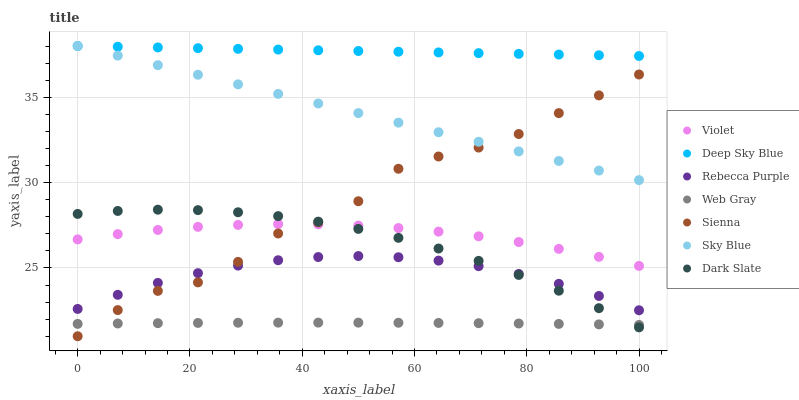Does Web Gray have the minimum area under the curve?
Answer yes or no. Yes. Does Deep Sky Blue have the maximum area under the curve?
Answer yes or no. Yes. Does Sienna have the minimum area under the curve?
Answer yes or no. No. Does Sienna have the maximum area under the curve?
Answer yes or no. No. Is Sky Blue the smoothest?
Answer yes or no. Yes. Is Sienna the roughest?
Answer yes or no. Yes. Is Dark Slate the smoothest?
Answer yes or no. No. Is Dark Slate the roughest?
Answer yes or no. No. Does Sienna have the lowest value?
Answer yes or no. Yes. Does Dark Slate have the lowest value?
Answer yes or no. No. Does Sky Blue have the highest value?
Answer yes or no. Yes. Does Sienna have the highest value?
Answer yes or no. No. Is Sienna less than Deep Sky Blue?
Answer yes or no. Yes. Is Deep Sky Blue greater than Web Gray?
Answer yes or no. Yes. Does Rebecca Purple intersect Dark Slate?
Answer yes or no. Yes. Is Rebecca Purple less than Dark Slate?
Answer yes or no. No. Is Rebecca Purple greater than Dark Slate?
Answer yes or no. No. Does Sienna intersect Deep Sky Blue?
Answer yes or no. No. 